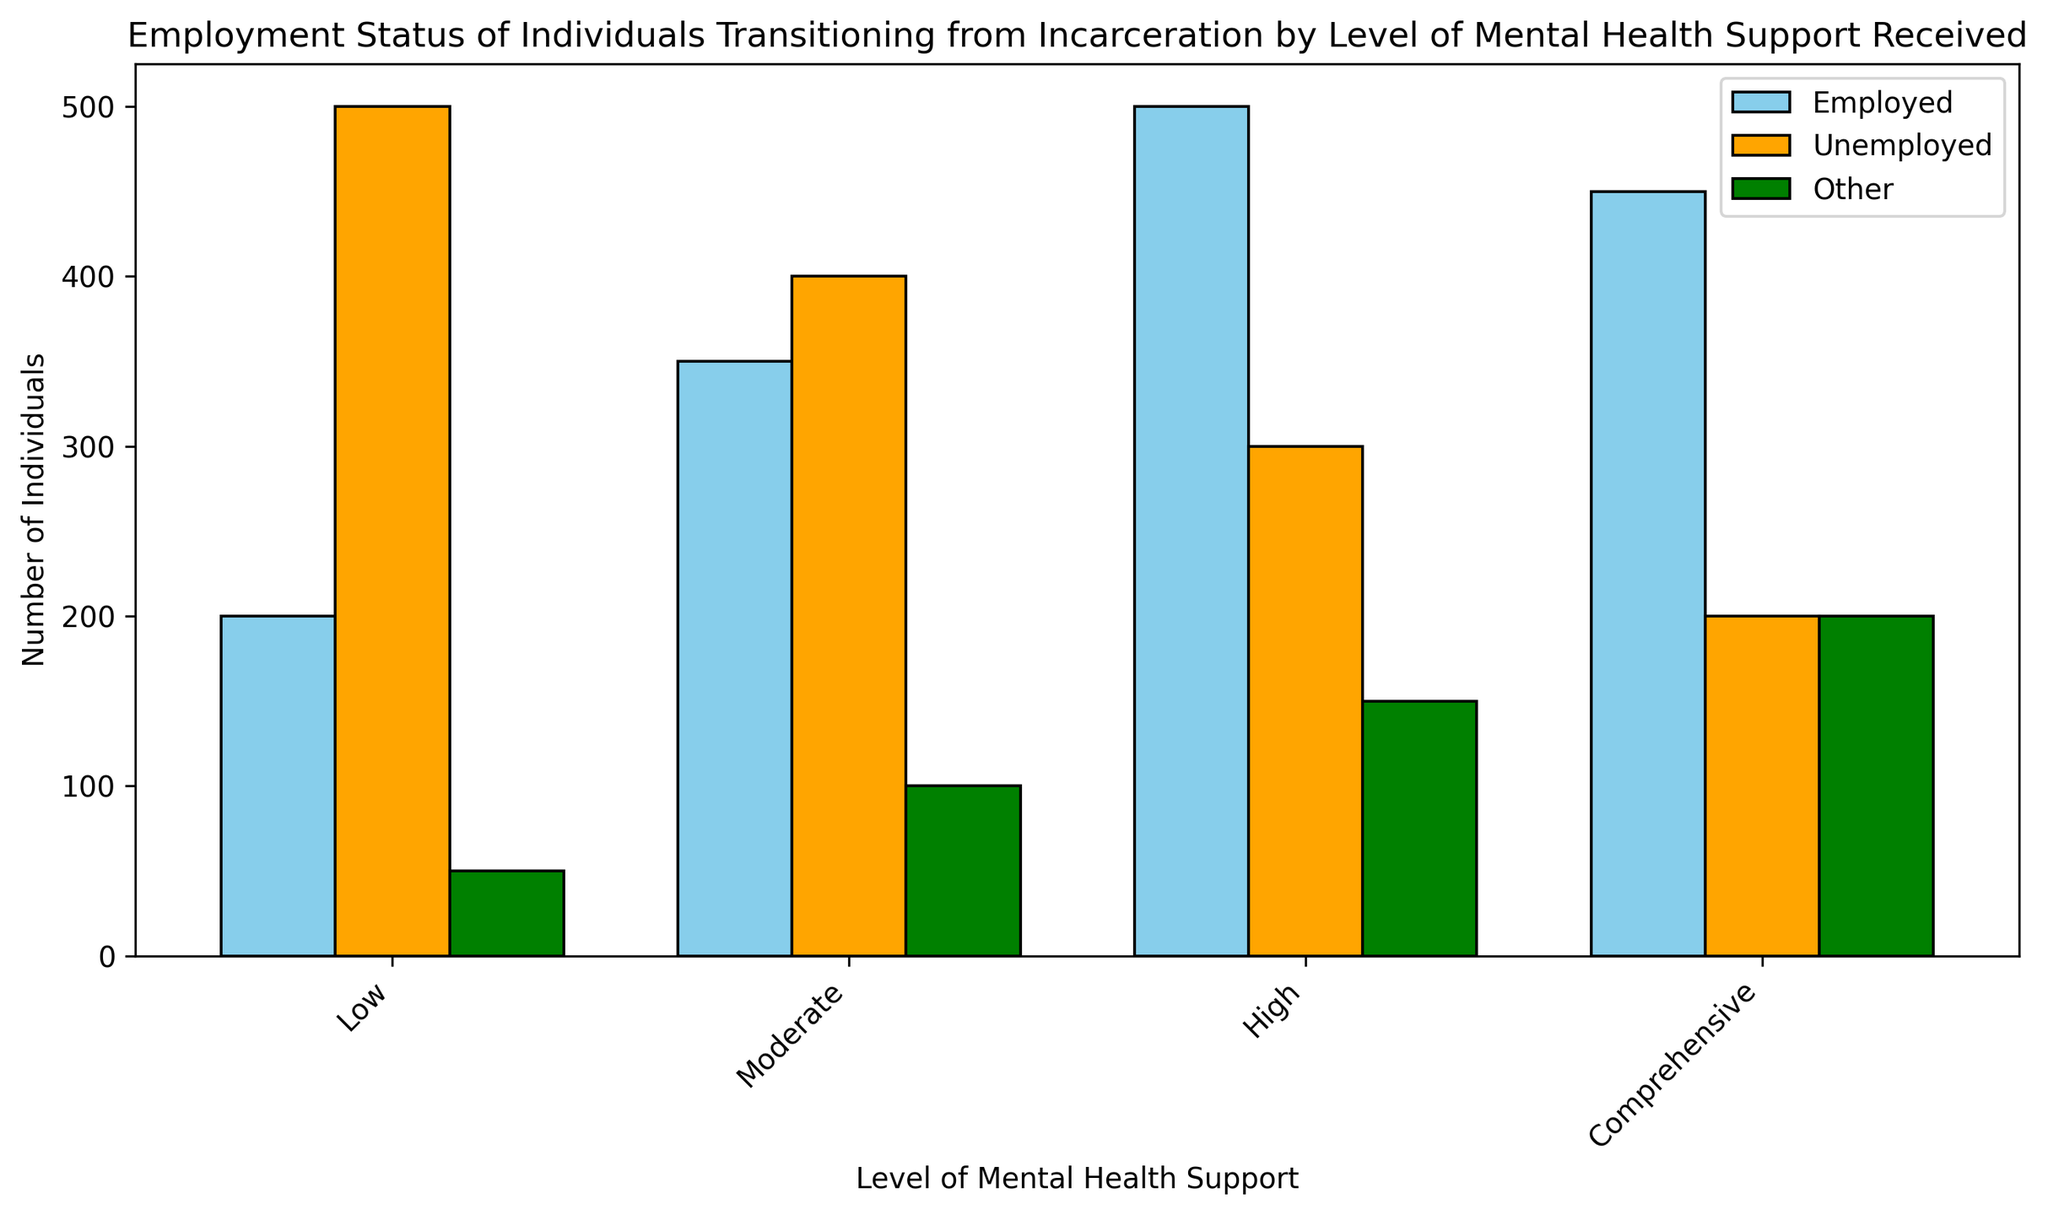Which category has the highest number of employed individuals? In the figure, the highest bar in the 'Employed' category is for the 'High' mental health support level.
Answer: High Which level of mental health support sees the lowest number of unemployed individuals? The lowest bar in the 'Unemployed' category is for the 'Comprehensive' level of mental health support.
Answer: Comprehensive How many more individuals are employed in the 'High' mental health support group compared to the 'Low' group? Subtract the number of employed in the 'Low' group (200) from the number in the 'High' group (500): 500 - 200 = 300.
Answer: 300 What is the total number of individuals categorized as 'Other' across all levels of mental health support? Sum the 'Other' category values: 50 (Low) + 100 (Moderate) + 150 (High) + 200 (Comprehensive) = 500.
Answer: 500 Which group has the largest combined total of individuals across all employment statuses? Sum the values for each group:
- Low: 200 + 500 + 50 = 750
- Moderate: 350 + 400 + 100 = 850
- High: 500 + 300 + 150 = 950
- Comprehensive: 450 + 200 + 200 = 850
The 'High' level has the largest combined total (950).
Answer: High How many individuals in total are either employed or unemployed at the moderate mental health support level? Add the values of 'Employed' and 'Unemployed' for moderate support: 350 + 400 = 750.
Answer: 750 Which employment status category has the most similar number of individuals in the 'Moderate' and 'High' mental health support levels? Compare the differences:
- Employed: 500 (High) - 350 (Moderate) = 150
- Unemployed: 400 (Moderate) - 300 (High) = 100
- Other: 150 (High) - 100 (Moderate) = 50
The 'Other' category has the smallest difference (50).
Answer: Other What is the average number of unemployed individuals across all mental health support levels? Sum the 'Unemployed' values and divide by the number of categories: (500 + 400 + 300 + 200) / 4 = 1400 / 4 = 350.
Answer: 350 Which level of mental health support has the greatest difference between the number of employed and unemployed individuals? Calculate the differences:
- Low: 500 - 200 = 300
- Moderate: 400 - 350 = 50
- High: 300 - 500 = negative, so 500 - 300 = 200
- Comprehensive: 200 - 450 = negative, so 450 - 200 = 250
The 'Low' level has the greatest difference (300).
Answer: Low 